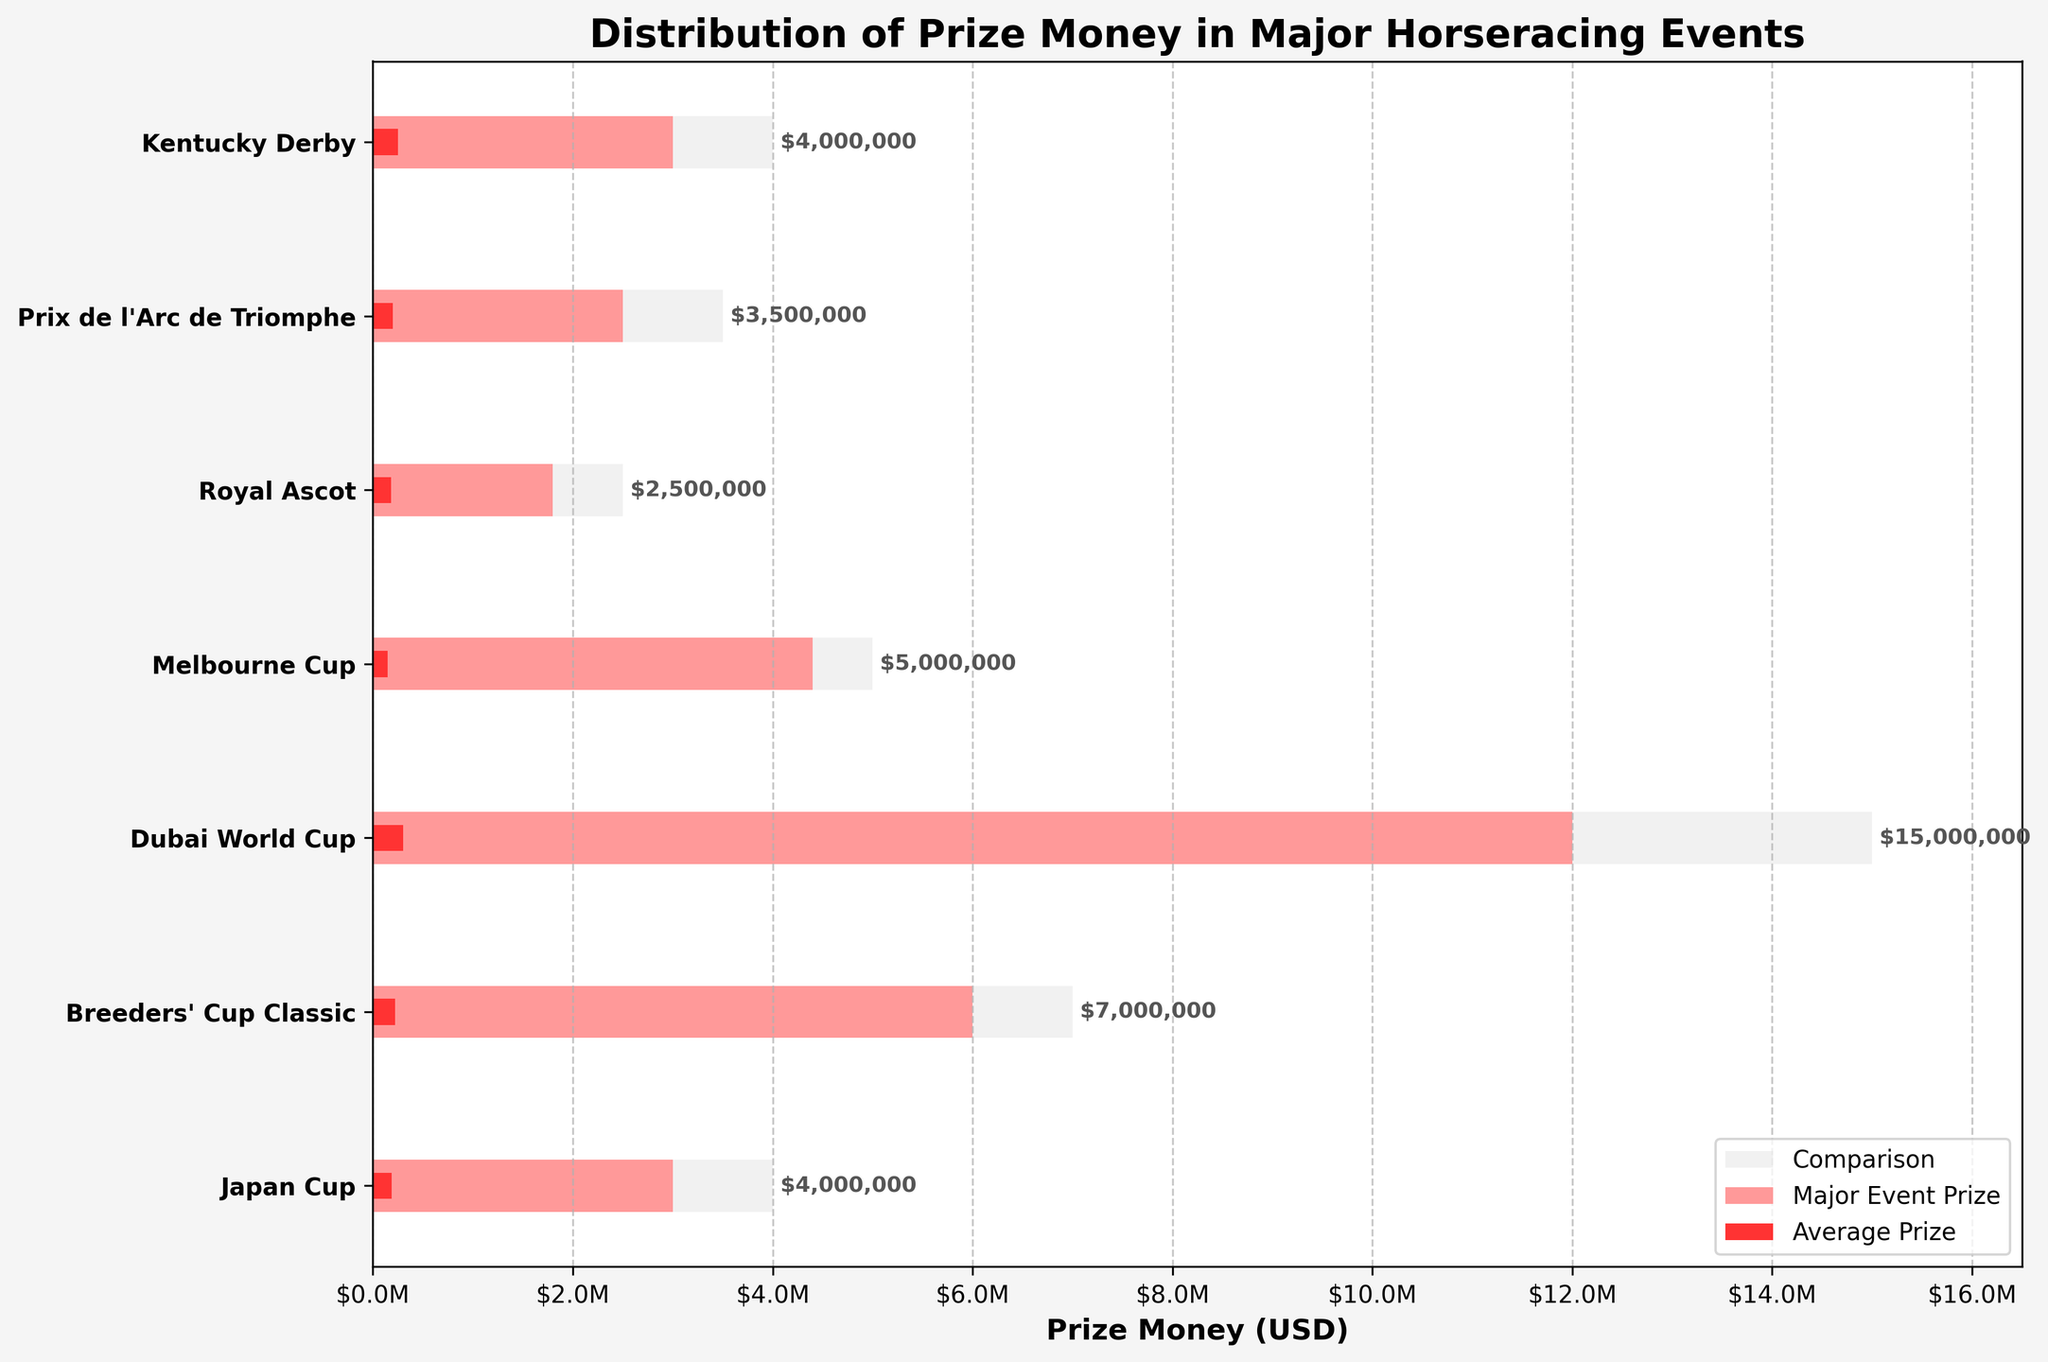Which event has the highest prize money for major events? The Dubai World Cup has the highest prize money for major events. This is found by identifying the event with the longest pink bar on the horizontal axis.
Answer: Dubai World Cup What is the title of the chart? The title is written at the top of the chart in bold text.
Answer: Distribution of Prize Money in Major Horseracing Events Which event's major prize money is closest to the industry average comparison? The Royal Ascot's major prize money is closest to its comparison value. This can be seen by comparing the lengths of the bars for each event.
Answer: Royal Ascot For which event is the major prize more than twenty times the average prize? Identify the event where the major prize divided by the average prize is greater than 20. For the Melbourne Cup, the major prize is $4,400,000 while the average prize is $150,000; 4,400,000 / 150,000 = 29.33.
Answer: Melbourne Cup How much is the average prize for the Breeders' Cup Classic? The value of the red bar representing the average prize should be checked under the Breeders' Cup Classic.
Answer: $220,000 Which two events have an average prize money less than $200,000? Identify the events with the red bars shorter than $200,000 on the horizontal axis.
Answer: Royal Ascot and Melbourne Cup What is the difference in the prize money between the major event prize and the average prize for the Japan Cup? Subtract the average prize from the major event prize for the Japan Cup. Major Event Prize ($3,000,000) - Average Prize ($190,000) = $2,810,000.
Answer: $2,810,000 Which event's major event prize and comparison value are exactly the same? Identify the event where the pink and grey bars are of equal length.
Answer: None How does the Breeders' Cup Classic's comparison prize money compare to the average prize money of the Dubai World Cup? Check the bar lengths for both values; the Dubai World Cup average prize money ($300,000) is compared to the Breeders' Cup Classic's comparison prize ($7,000,000).
Answer: Breeders' Cup Classic comparison is much higher 